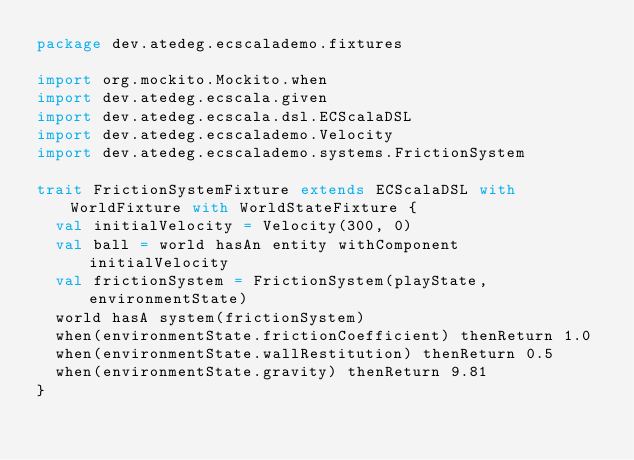<code> <loc_0><loc_0><loc_500><loc_500><_Scala_>package dev.atedeg.ecscalademo.fixtures

import org.mockito.Mockito.when
import dev.atedeg.ecscala.given
import dev.atedeg.ecscala.dsl.ECScalaDSL
import dev.atedeg.ecscalademo.Velocity
import dev.atedeg.ecscalademo.systems.FrictionSystem

trait FrictionSystemFixture extends ECScalaDSL with WorldFixture with WorldStateFixture {
  val initialVelocity = Velocity(300, 0)
  val ball = world hasAn entity withComponent initialVelocity
  val frictionSystem = FrictionSystem(playState, environmentState)
  world hasA system(frictionSystem)
  when(environmentState.frictionCoefficient) thenReturn 1.0
  when(environmentState.wallRestitution) thenReturn 0.5
  when(environmentState.gravity) thenReturn 9.81
}
</code> 